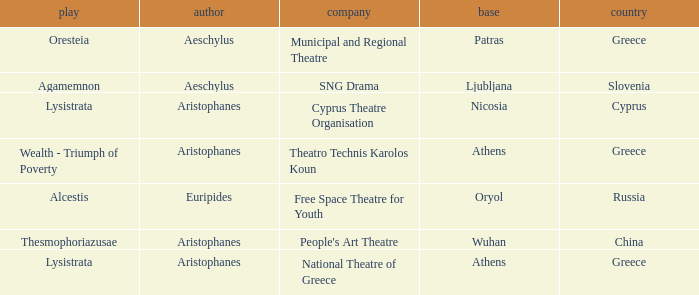What is the base when the play is thesmophoriazusae? Wuhan. 